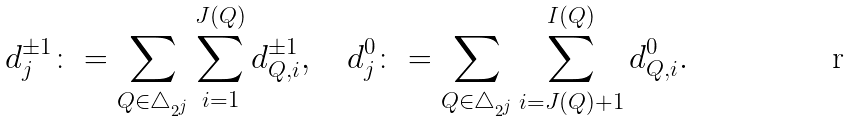<formula> <loc_0><loc_0><loc_500><loc_500>d ^ { \pm 1 } _ { j } \colon = \sum _ { Q \in \triangle _ { 2 ^ { j } } } \sum _ { i = 1 } ^ { J ( Q ) } d ^ { \pm 1 } _ { Q , i } , \quad d ^ { 0 } _ { j } \colon = \sum _ { Q \in \triangle _ { 2 ^ { j } } } \sum _ { i = J ( Q ) + 1 } ^ { I ( Q ) } d ^ { 0 } _ { Q , i } .</formula> 